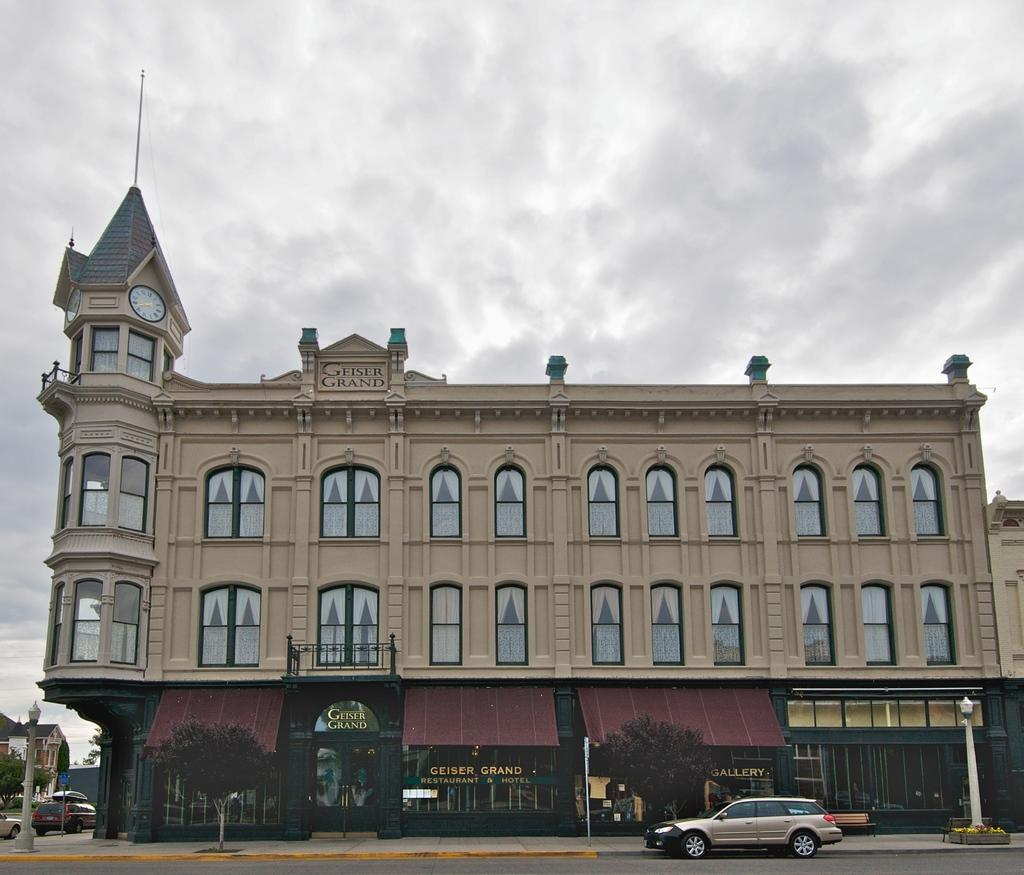What is the main structure in the center of the image? There is a building in the center of the image. What other objects can be seen at the bottom of the image? Trees and poles are present at the bottom of the image. What type of vehicles are visible in the image? Cars are visible in the image. What is on the left side of the image? There are buildings on the left side of the image. What can be seen in the background of the image? The sky is visible in the background of the image. What type of fruit is hanging from the trees in the image? There is no fruit hanging from the trees in the image; only trees and poles are present at the bottom. 